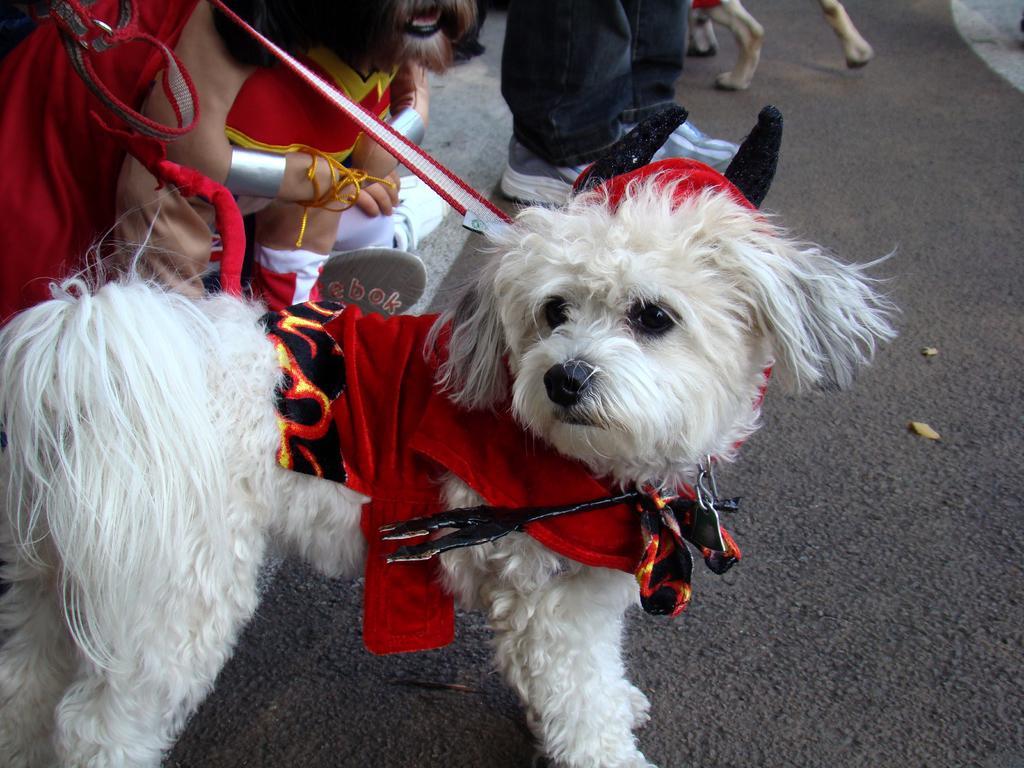Please provide a concise description of this image. In this image we can see white color dog wearing red color dress. Behind persons are there. 